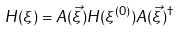Convert formula to latex. <formula><loc_0><loc_0><loc_500><loc_500>H ( \xi ) = A ( \vec { \xi } ) H ( \xi ^ { ( 0 ) } ) A ( \vec { \xi } ) ^ { \dagger }</formula> 